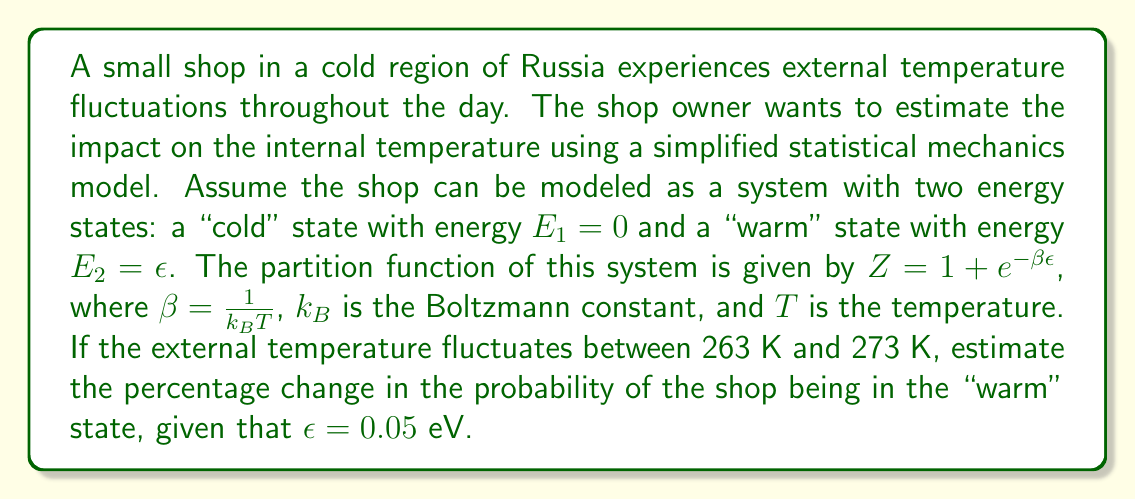Can you answer this question? Let's approach this step-by-step:

1) The probability of the system being in the "warm" state is given by:

   $P_2 = \frac{e^{-\beta\epsilon}}{Z} = \frac{e^{-\beta\epsilon}}{1 + e^{-\beta\epsilon}}$

2) We need to calculate this probability for both temperatures and compare them.

3) First, let's calculate $\beta$ for both temperatures:
   
   At 263 K: $\beta_1 = \frac{1}{k_BT} = \frac{1}{(8.617 \times 10^{-5} \text{ eV/K})(263 \text{ K})} = 44.15 \text{ eV}^{-1}$
   
   At 273 K: $\beta_2 = \frac{1}{k_BT} = \frac{1}{(8.617 \times 10^{-5} \text{ eV/K})(273 \text{ K})} = 42.54 \text{ eV}^{-1}$

4) Now, let's calculate the probabilities:

   At 263 K: $P_2(263K) = \frac{e^{-44.15 \times 0.05}}{1 + e^{-44.15 \times 0.05}} = 0.1082$
   
   At 273 K: $P_2(273K) = \frac{e^{-42.54 \times 0.05}}{1 + e^{-42.54 \times 0.05}} = 0.1159$

5) To calculate the percentage change:

   $\text{Percentage Change} = \frac{P_2(273K) - P_2(263K)}{P_2(263K)} \times 100\%$
   
   $= \frac{0.1159 - 0.1082}{0.1082} \times 100\% = 7.12\%$
Answer: 7.12% 